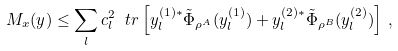<formula> <loc_0><loc_0><loc_500><loc_500>M _ { x } ( y ) \leq \sum _ { l } c _ { l } ^ { 2 } \ t r \left [ y _ { l } ^ { ( 1 ) * } \tilde { \Phi } _ { \rho ^ { A } } ( y _ { l } ^ { ( 1 ) } ) + y _ { l } ^ { ( 2 ) * } \tilde { \Phi } _ { \rho ^ { B } } ( y _ { l } ^ { ( 2 ) } ) \right ] \, ,</formula> 